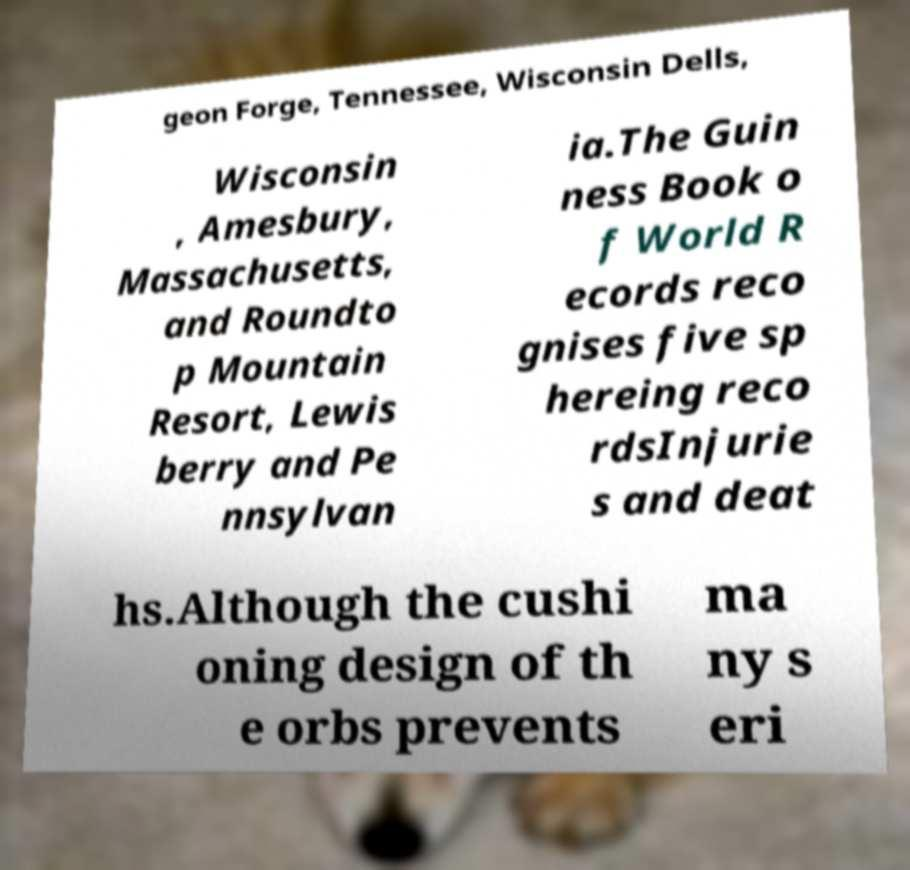For documentation purposes, I need the text within this image transcribed. Could you provide that? geon Forge, Tennessee, Wisconsin Dells, Wisconsin , Amesbury, Massachusetts, and Roundto p Mountain Resort, Lewis berry and Pe nnsylvan ia.The Guin ness Book o f World R ecords reco gnises five sp hereing reco rdsInjurie s and deat hs.Although the cushi oning design of th e orbs prevents ma ny s eri 